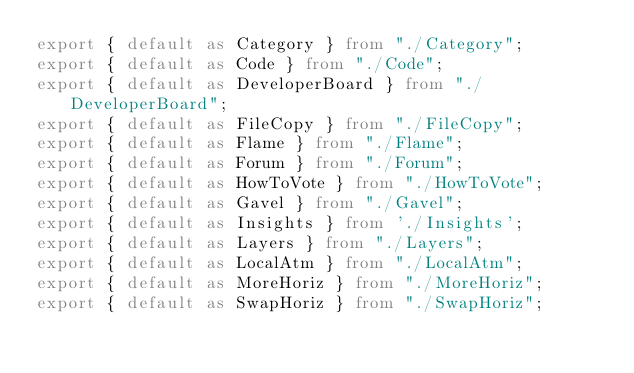<code> <loc_0><loc_0><loc_500><loc_500><_TypeScript_>export { default as Category } from "./Category";
export { default as Code } from "./Code";
export { default as DeveloperBoard } from "./DeveloperBoard"; 
export { default as FileCopy } from "./FileCopy";
export { default as Flame } from "./Flame";
export { default as Forum } from "./Forum";
export { default as HowToVote } from "./HowToVote";
export { default as Gavel } from "./Gavel";
export { default as Insights } from './Insights';
export { default as Layers } from "./Layers";
export { default as LocalAtm } from "./LocalAtm";
export { default as MoreHoriz } from "./MoreHoriz";
export { default as SwapHoriz } from "./SwapHoriz";</code> 